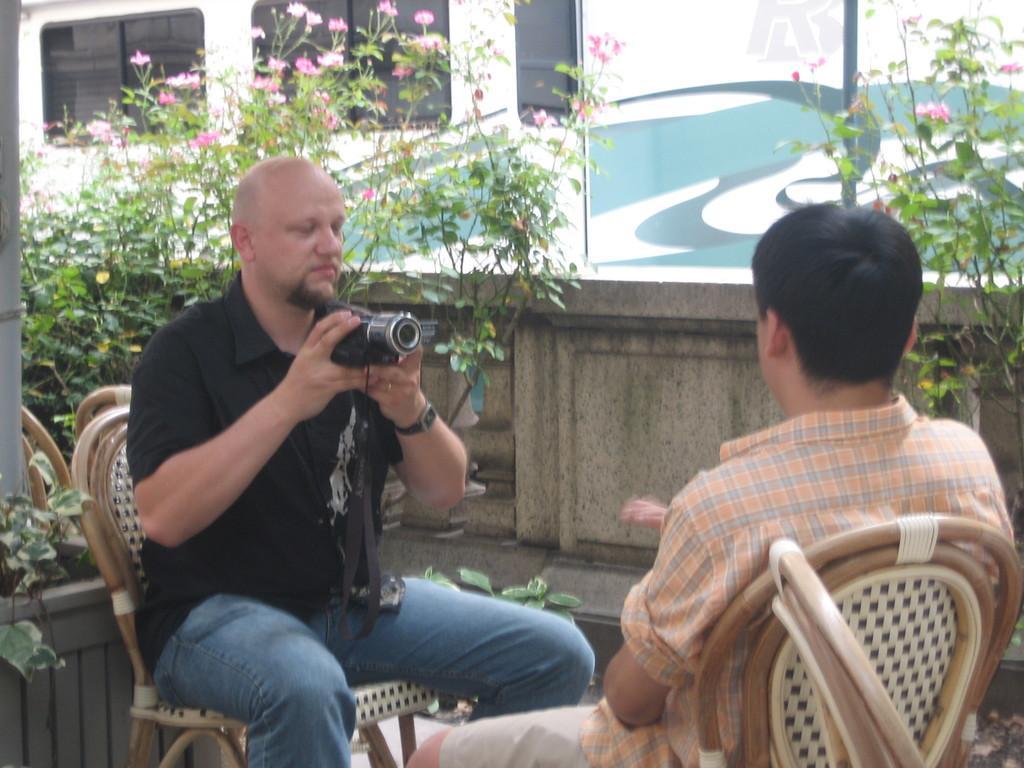Describe this image in one or two sentences. In this picture we can see two men sitting on chairs, a man on the left side is holding a camera, in the background there are some plants, we can see flowers here, there is a vehicle here. 